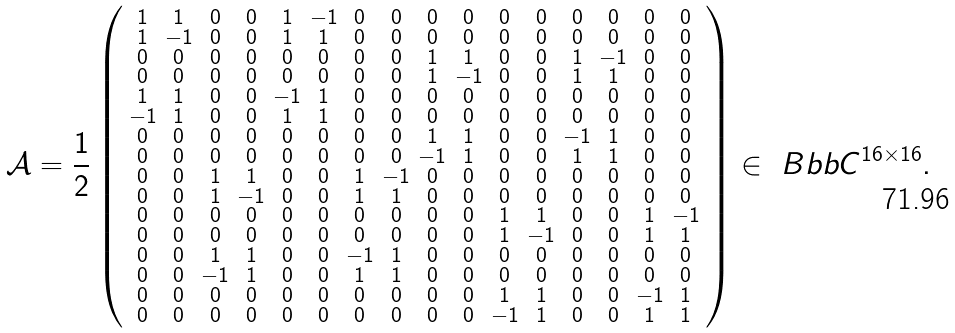Convert formula to latex. <formula><loc_0><loc_0><loc_500><loc_500>\mathcal { A } = \frac { 1 } { 2 } \left ( \begin{smallmatrix} 1 & 1 & 0 & 0 & 1 & - 1 & 0 & 0 & 0 & 0 & 0 & 0 & 0 & 0 & 0 & 0 \\ 1 & - 1 & 0 & 0 & 1 & 1 & 0 & 0 & 0 & 0 & 0 & 0 & 0 & 0 & 0 & 0 \\ 0 & 0 & 0 & 0 & 0 & 0 & 0 & 0 & 1 & 1 & 0 & 0 & 1 & - 1 & 0 & 0 \\ 0 & 0 & 0 & 0 & 0 & 0 & 0 & 0 & 1 & - 1 & 0 & 0 & 1 & 1 & 0 & 0 \\ 1 & 1 & 0 & 0 & - 1 & 1 & 0 & 0 & 0 & 0 & 0 & 0 & 0 & 0 & 0 & 0 \\ - 1 & 1 & 0 & 0 & 1 & 1 & 0 & 0 & 0 & 0 & 0 & 0 & 0 & 0 & 0 & 0 \\ 0 & 0 & 0 & 0 & 0 & 0 & 0 & 0 & 1 & 1 & 0 & 0 & - 1 & 1 & 0 & 0 \\ 0 & 0 & 0 & 0 & 0 & 0 & 0 & 0 & - 1 & 1 & 0 & 0 & 1 & 1 & 0 & 0 \\ 0 & 0 & 1 & 1 & 0 & 0 & 1 & - 1 & 0 & 0 & 0 & 0 & 0 & 0 & 0 & 0 \\ 0 & 0 & 1 & - 1 & 0 & 0 & 1 & 1 & 0 & 0 & 0 & 0 & 0 & 0 & 0 & 0 \\ 0 & 0 & 0 & 0 & 0 & 0 & 0 & 0 & 0 & 0 & 1 & 1 & 0 & 0 & 1 & - 1 \\ 0 & 0 & 0 & 0 & 0 & 0 & 0 & 0 & 0 & 0 & 1 & - 1 & 0 & 0 & 1 & 1 \\ 0 & 0 & 1 & 1 & 0 & 0 & - 1 & 1 & 0 & 0 & 0 & 0 & 0 & 0 & 0 & 0 \\ 0 & 0 & - 1 & 1 & 0 & 0 & 1 & 1 & 0 & 0 & 0 & 0 & 0 & 0 & 0 & 0 \\ 0 & 0 & 0 & 0 & 0 & 0 & 0 & 0 & 0 & 0 & 1 & 1 & 0 & 0 & - 1 & 1 \\ 0 & 0 & 0 & 0 & 0 & 0 & 0 & 0 & 0 & 0 & - 1 & 1 & 0 & 0 & 1 & 1 \end{smallmatrix} \right ) \in \ B b b { C } ^ { 1 6 \times 1 6 } .</formula> 